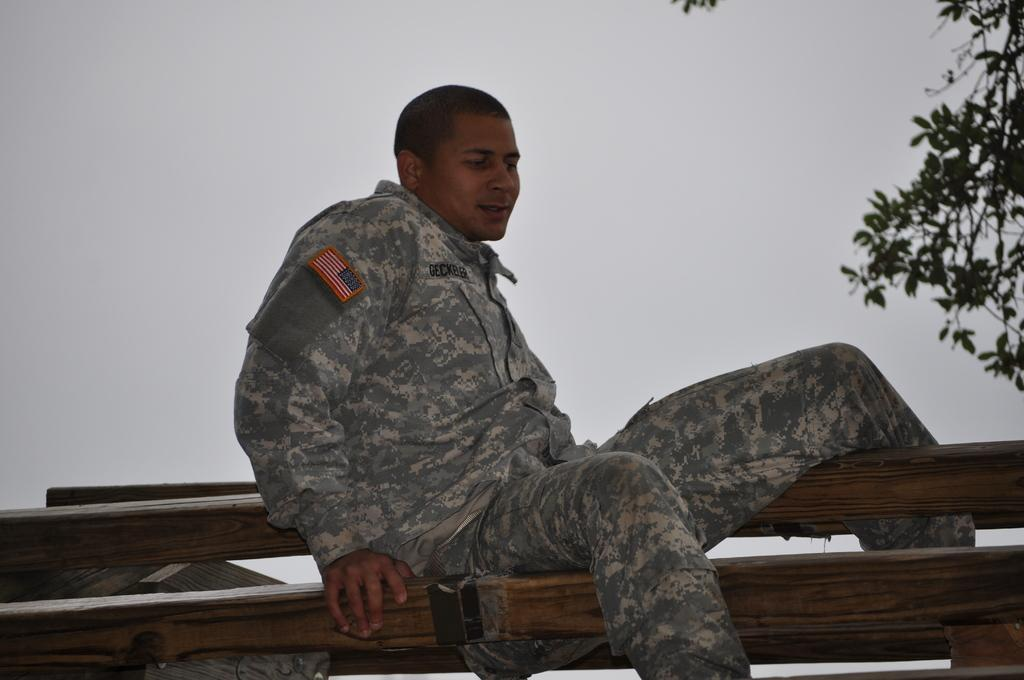What is the man in the image doing? There is a man sitting in the image. What type of structure can be seen in the image? There is a wooden fence in the image. What type of plant is visible in the image? There is a tree in the image. What can be seen in the background of the image? The sky is visible in the background of the image. What type of soup is being served in the image? There is no soup present in the image. What type of waste can be seen in the image? There is no waste present in the image. 